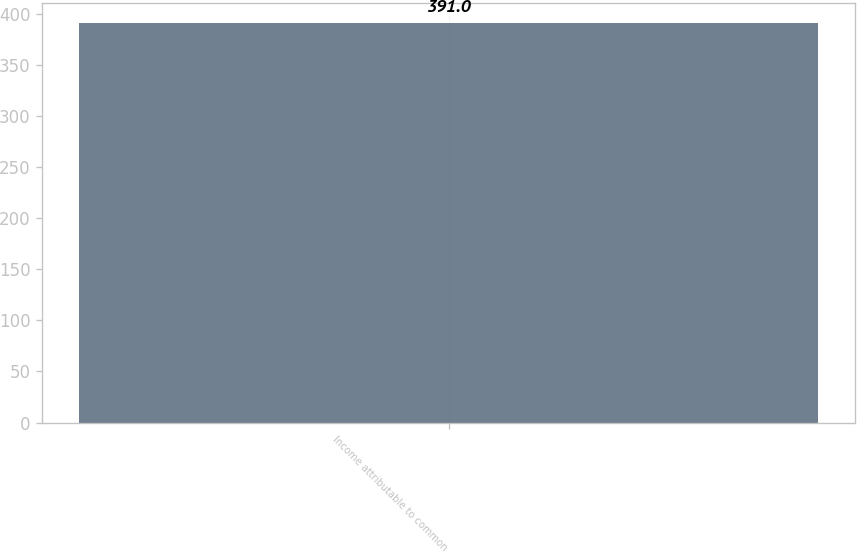<chart> <loc_0><loc_0><loc_500><loc_500><bar_chart><fcel>Income attributable to common<nl><fcel>391<nl></chart> 